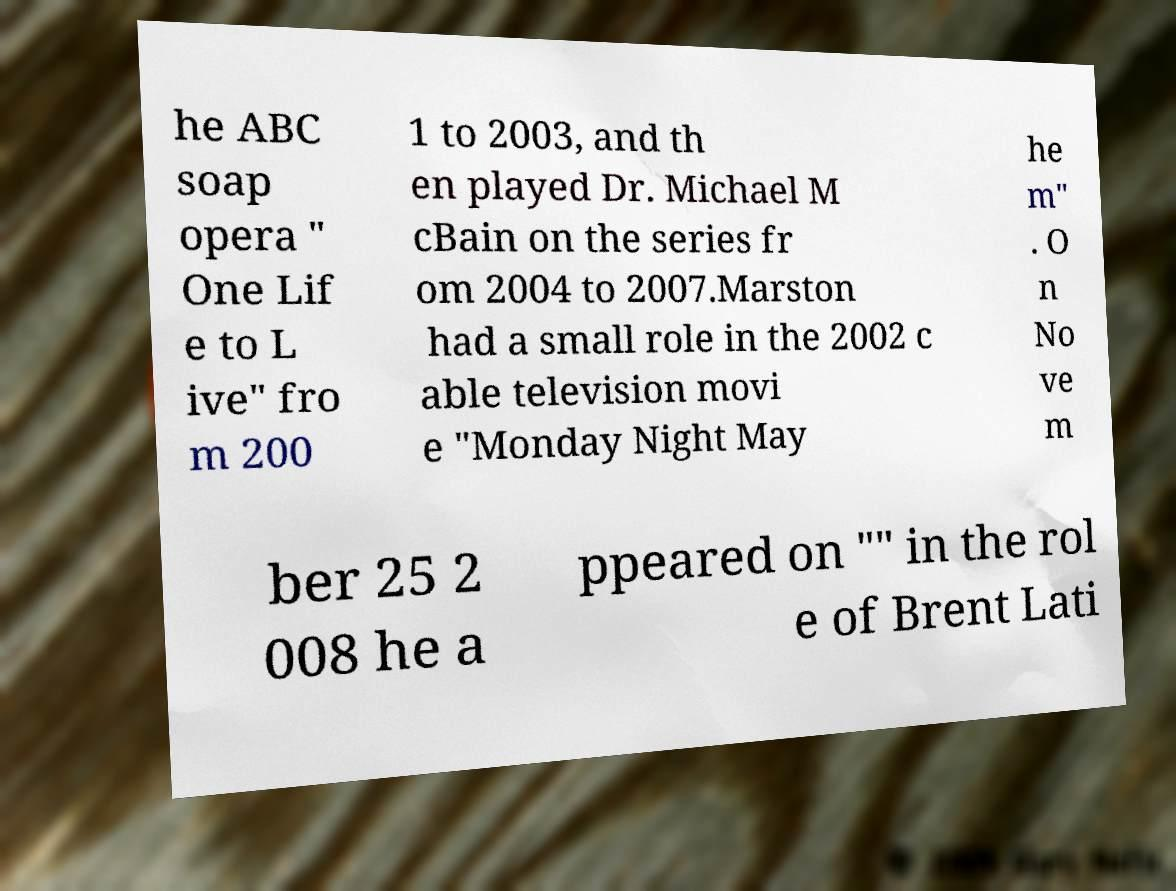Could you extract and type out the text from this image? he ABC soap opera " One Lif e to L ive" fro m 200 1 to 2003, and th en played Dr. Michael M cBain on the series fr om 2004 to 2007.Marston had a small role in the 2002 c able television movi e "Monday Night May he m" . O n No ve m ber 25 2 008 he a ppeared on "" in the rol e of Brent Lati 